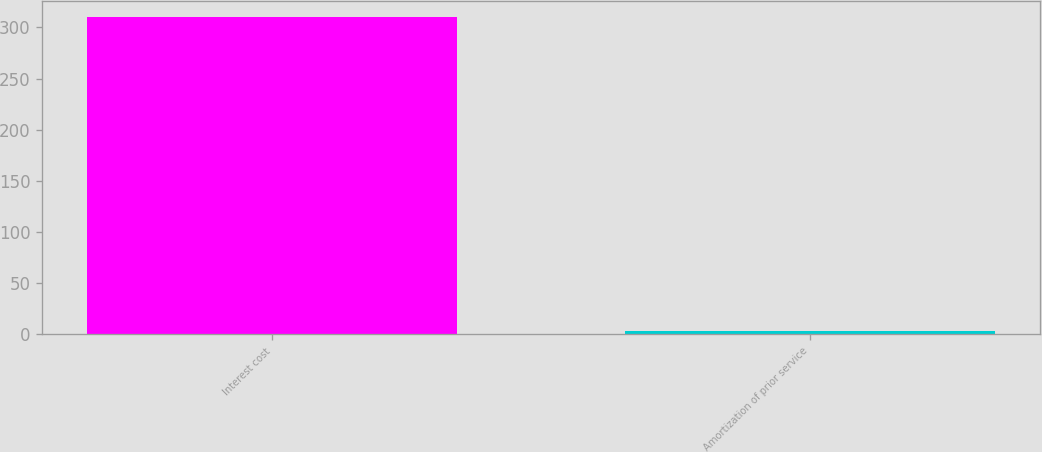<chart> <loc_0><loc_0><loc_500><loc_500><bar_chart><fcel>Interest cost<fcel>Amortization of prior service<nl><fcel>310<fcel>3<nl></chart> 